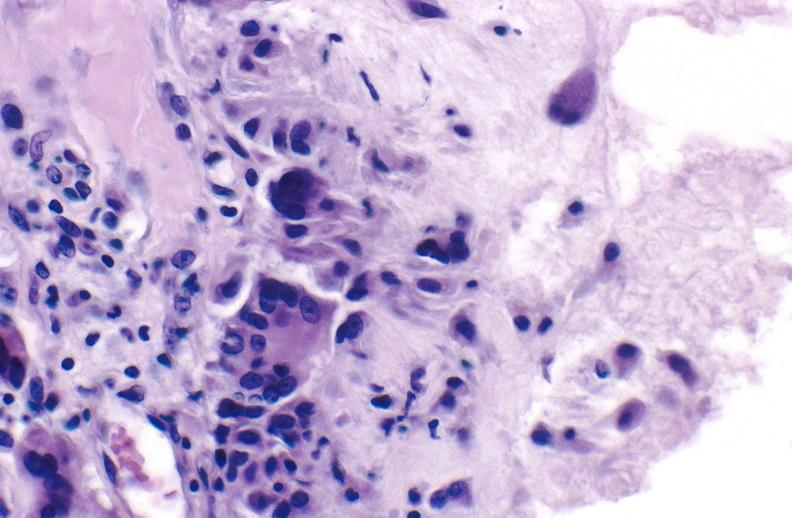does this image show gout?
Answer the question using a single word or phrase. Yes 